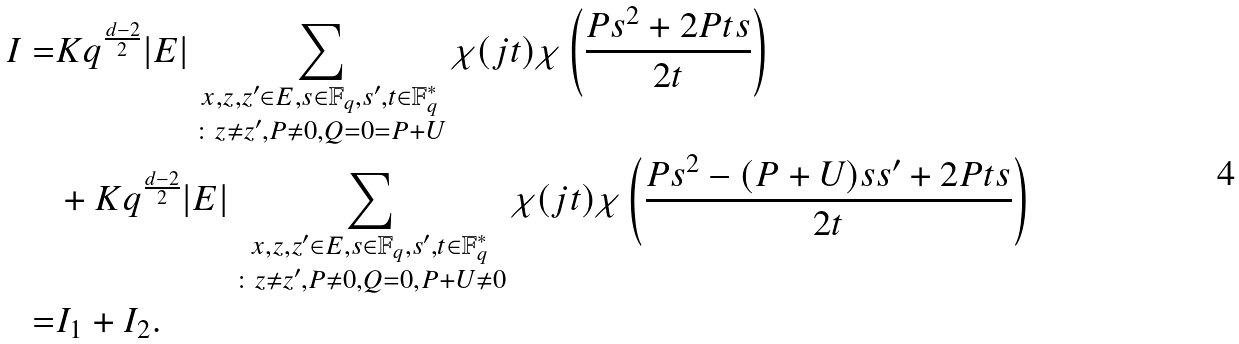Convert formula to latex. <formula><loc_0><loc_0><loc_500><loc_500>I = & K q ^ { \frac { d - 2 } { 2 } } | E | \sum _ { \substack { x , z , z ^ { \prime } \in E , s \in { \mathbb { F } } _ { q } , s ^ { \prime } , t \in { \mathbb { F } } _ { q } ^ { * } \\ \colon z \neq z ^ { \prime } , P \neq 0 , Q = 0 = P + U } } \chi ( j t ) \chi \left ( \frac { P s ^ { 2 } + 2 P t s } { 2 t } \right ) \\ & + K q ^ { \frac { d - 2 } { 2 } } | E | \sum _ { \substack { x , z , z ^ { \prime } \in E , s \in { \mathbb { F } } _ { q } , s ^ { \prime } , t \in { \mathbb { F } } _ { q } ^ { * } \\ \colon z \neq z ^ { \prime } , P \neq 0 , Q = 0 , P + U \neq 0 } } \chi ( j t ) \chi \left ( \frac { P s ^ { 2 } - ( P + U ) s s ^ { \prime } + 2 P t s } { 2 t } \right ) \\ = & I _ { 1 } + I _ { 2 } .</formula> 